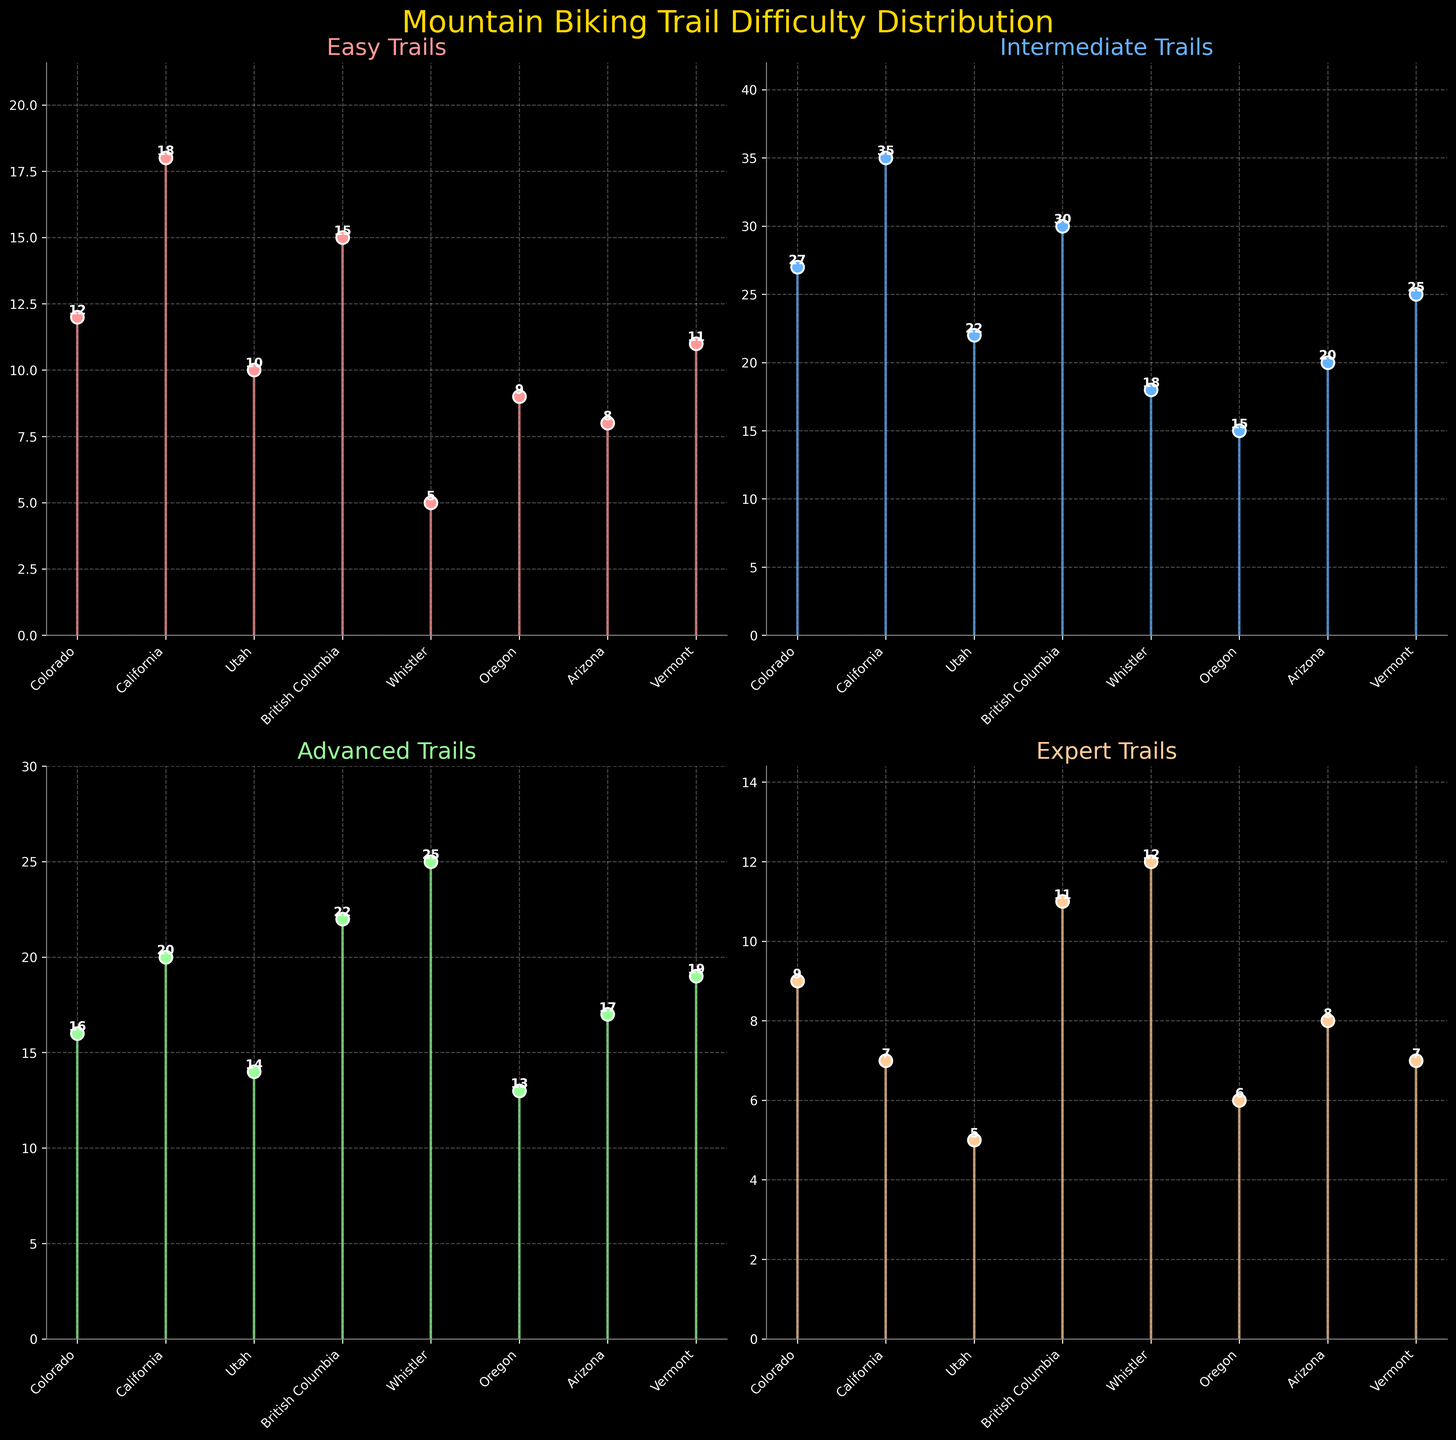Which region has the most easy trails? To find this, look at the 'Easy Trails' subplot. The region with the highest stem value indicates the most easy trails. Colorado is at 12, California is at 18, Utah is at 10, British Columbia is at 15, Whistler is at 5, Oregon is at 9, Arizona is at 8, and Vermont is at 11. California has the highest value.
Answer: California In which subplot does Whistler have the highest value? Examine each subplot to determine where Whistler's stem is the largest. Whistler has values of 5 for Easy, 18 for Intermediate, 25 for Advanced, and 12 for Expert trails. The highest value is in the 'Advanced Trails' subplot.
Answer: Advanced Trails What is the combined total of advanced trails in Arizona and Vermont? Look at the 'Advanced Trails' subplot for the values. Arizona shows 17 and Vermont shows 19. The total is 17 + 19.
Answer: 36 Considering the Intermediate Trails subplot, which region has the second-lowest number of trails? Evaluate the 'Intermediate Trails' subplot. The values are Colorado at 27, California at 35, Utah at 22, British Columbia at 30, Whistler at 18, Oregon at 15, Arizona at 20, and Vermont at 25. The second-lowest value is 18, found in Whistler; the lowest being 15 in Oregon.
Answer: Whistler How many easy trails are there in total across all regions? Add up the values from the 'Easy Trails' subplot. The values are Colorado at 12, California at 18, Utah at 10, British Columbia at 15, Whistler at 5, Oregon at 9, Arizona at 8, and Vermont at 11. The total is (12 + 18 + 10 + 15 + 5 + 9 + 8 + 11).
Answer: 88 Which region has the highest variability in trail difficulty levels? To determine this, compare the ranges for each region across all subplots. Calculate the range (difference between the highest and lowest values) for each region. The range for each region is as follows: Colorado (27-9=18), California (35-7=28), Utah (22-5=17), British Columbia (30-11=19), Whistler (25-5=20), Oregon (15-6=9), Arizona (20-8=12), Vermont (25-7=18). California has the highest range of 28.
Answer: California 